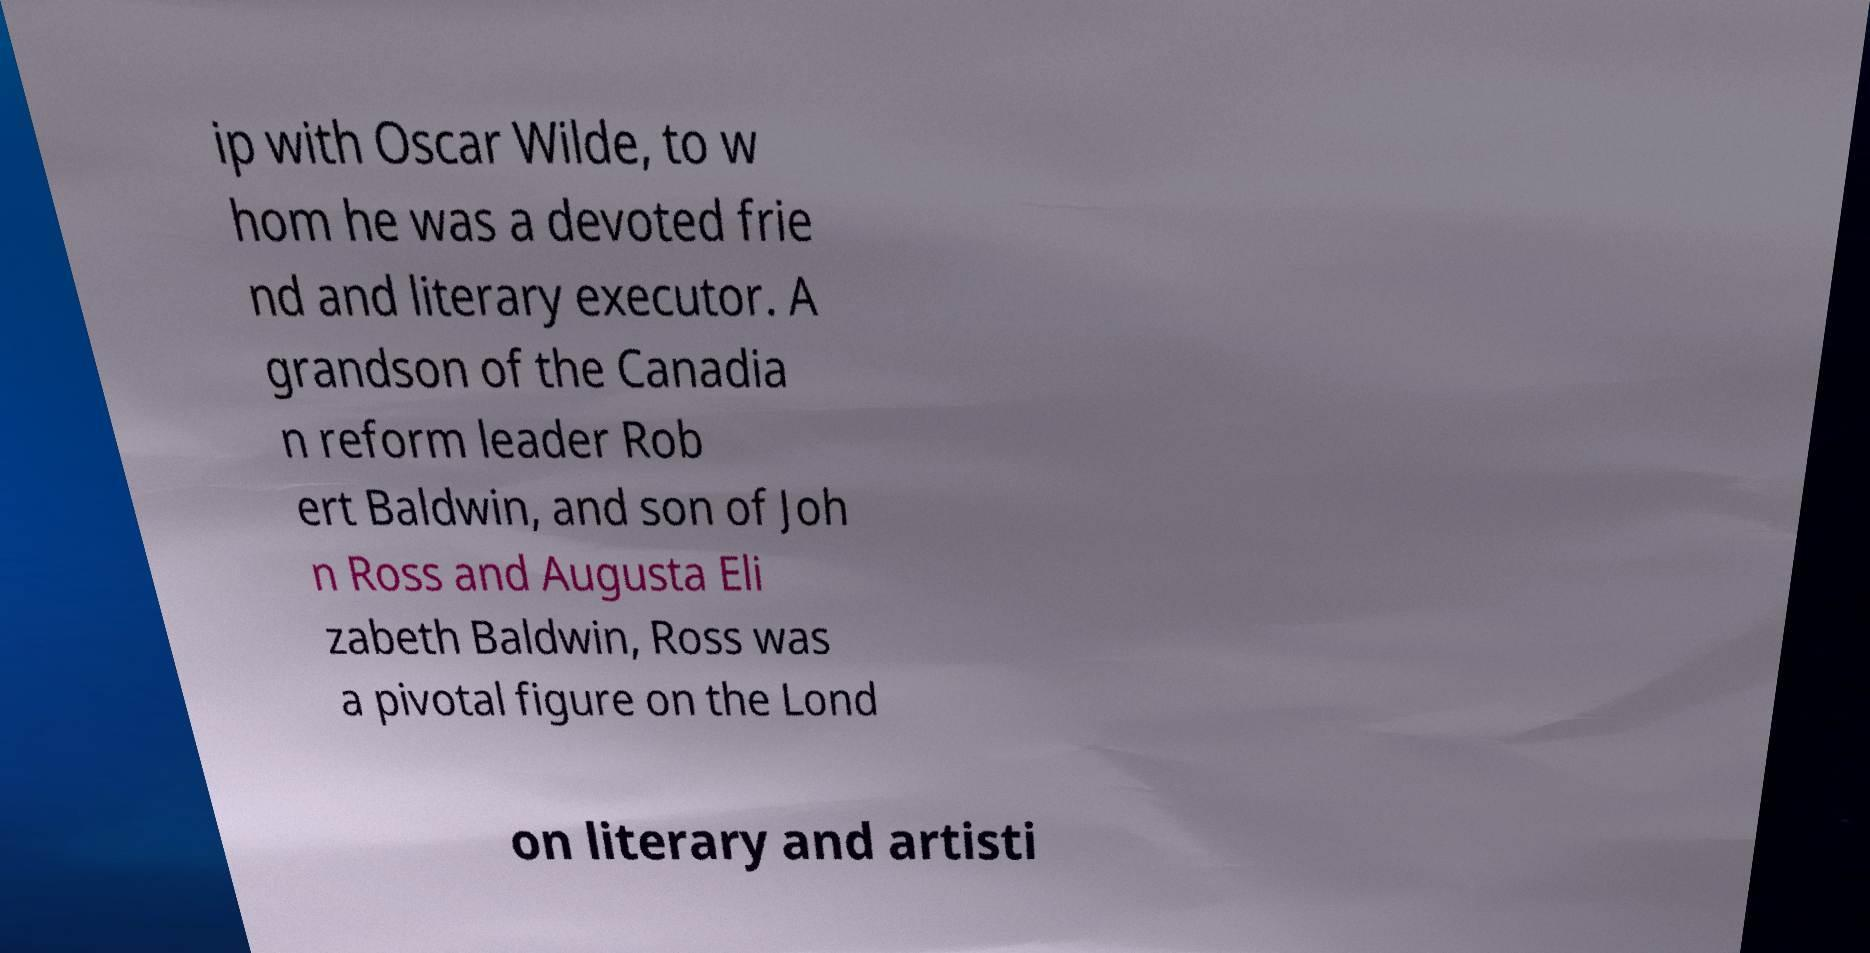There's text embedded in this image that I need extracted. Can you transcribe it verbatim? ip with Oscar Wilde, to w hom he was a devoted frie nd and literary executor. A grandson of the Canadia n reform leader Rob ert Baldwin, and son of Joh n Ross and Augusta Eli zabeth Baldwin, Ross was a pivotal figure on the Lond on literary and artisti 